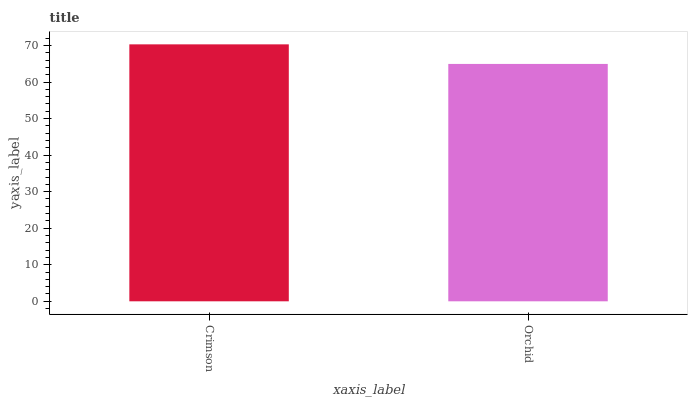Is Orchid the maximum?
Answer yes or no. No. Is Crimson greater than Orchid?
Answer yes or no. Yes. Is Orchid less than Crimson?
Answer yes or no. Yes. Is Orchid greater than Crimson?
Answer yes or no. No. Is Crimson less than Orchid?
Answer yes or no. No. Is Crimson the high median?
Answer yes or no. Yes. Is Orchid the low median?
Answer yes or no. Yes. Is Orchid the high median?
Answer yes or no. No. Is Crimson the low median?
Answer yes or no. No. 